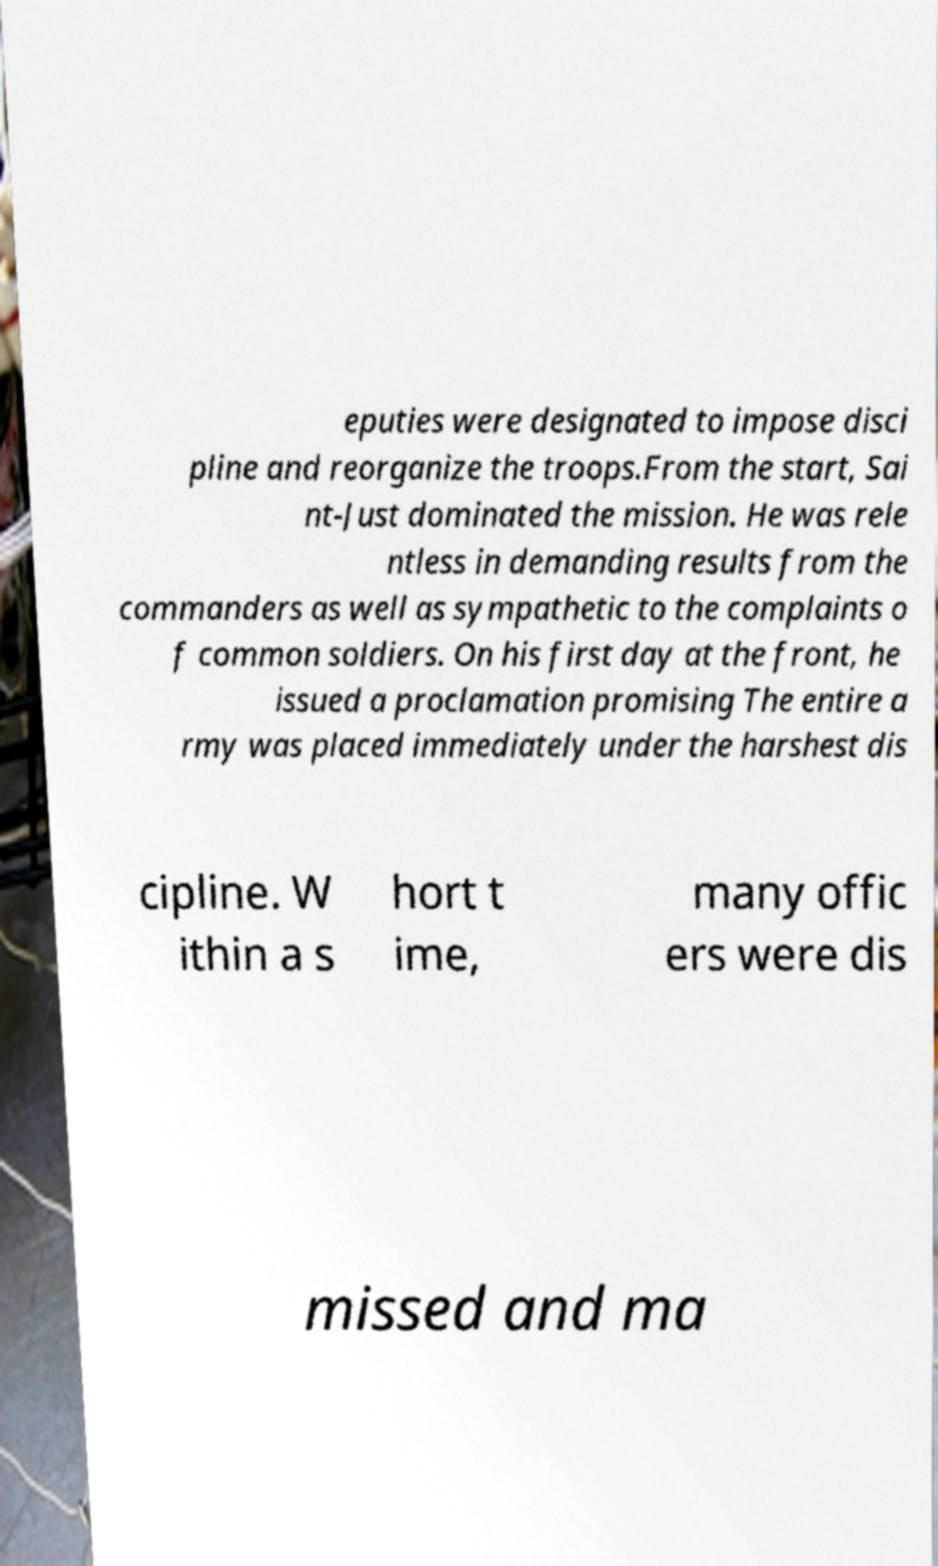Please identify and transcribe the text found in this image. eputies were designated to impose disci pline and reorganize the troops.From the start, Sai nt-Just dominated the mission. He was rele ntless in demanding results from the commanders as well as sympathetic to the complaints o f common soldiers. On his first day at the front, he issued a proclamation promising The entire a rmy was placed immediately under the harshest dis cipline. W ithin a s hort t ime, many offic ers were dis missed and ma 